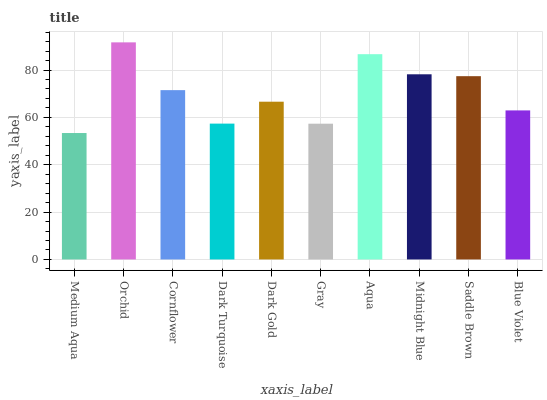Is Medium Aqua the minimum?
Answer yes or no. Yes. Is Orchid the maximum?
Answer yes or no. Yes. Is Cornflower the minimum?
Answer yes or no. No. Is Cornflower the maximum?
Answer yes or no. No. Is Orchid greater than Cornflower?
Answer yes or no. Yes. Is Cornflower less than Orchid?
Answer yes or no. Yes. Is Cornflower greater than Orchid?
Answer yes or no. No. Is Orchid less than Cornflower?
Answer yes or no. No. Is Cornflower the high median?
Answer yes or no. Yes. Is Dark Gold the low median?
Answer yes or no. Yes. Is Midnight Blue the high median?
Answer yes or no. No. Is Medium Aqua the low median?
Answer yes or no. No. 